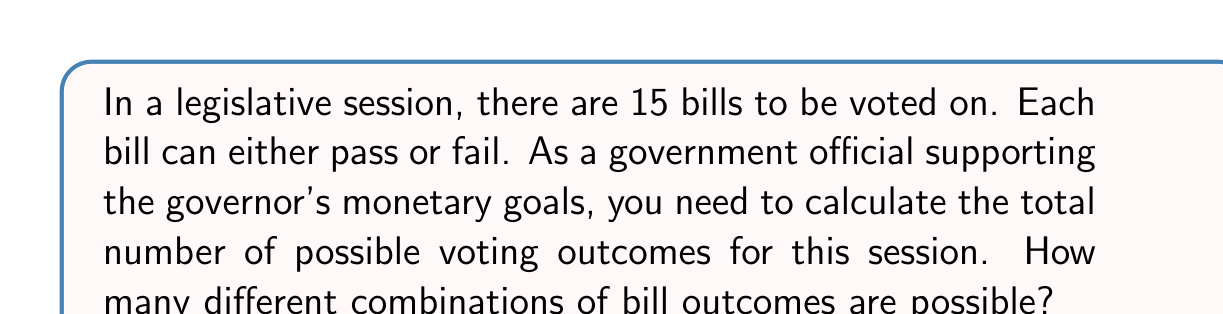Help me with this question. Let's approach this step-by-step:

1) For each bill, there are two possible outcomes: pass or fail.

2) We need to determine the number of ways these outcomes can occur for all 15 bills.

3) This is a perfect scenario for using the multiplication principle of counting.

4) For each bill, we have 2 choices, and we have this same number of choices for all 15 bills.

5) Therefore, we can represent this as:

   $$2 \times 2 \times 2 \times ... \times 2$$ (15 times)

6) This is equivalent to:

   $$2^{15}$$

7) To calculate this:

   $$2^{15} = 32,768$$

Thus, there are 32,768 possible combinations of bill outcomes in this legislative session.

This large number of possibilities underscores the importance of careful policy coordination to align with the governor's monetary goals, as each combination could have different fiscal implications.
Answer: $2^{15} = 32,768$ 